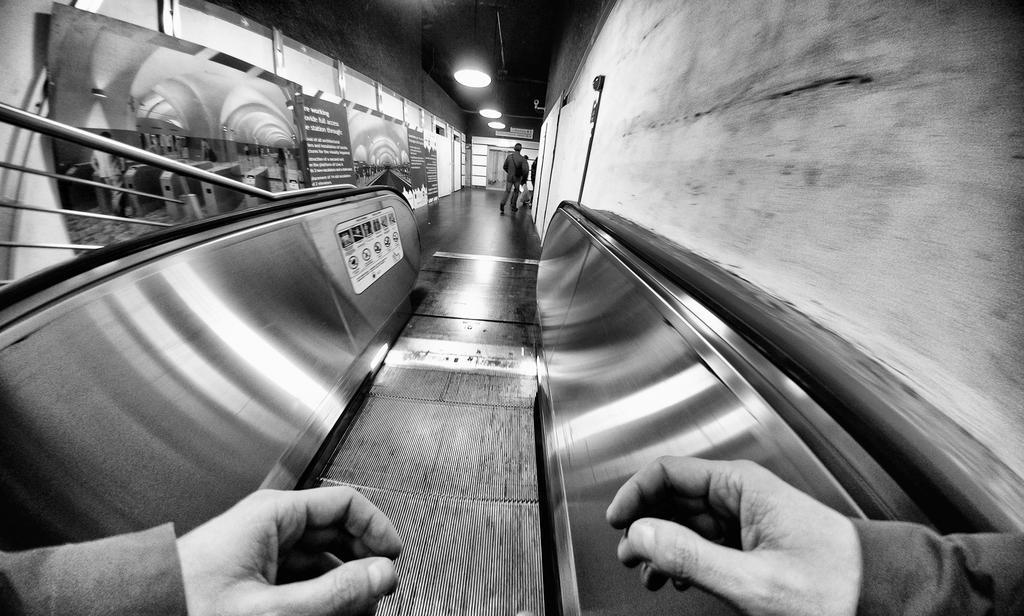Can you describe this image briefly? In this image at front there is a escalator and we can see two hands of a person. On both right and left side of the image there are walls. On the left side wall there are banners attached to the wall. At the backside people are walking on the floor. On top of the roof there are lights. 